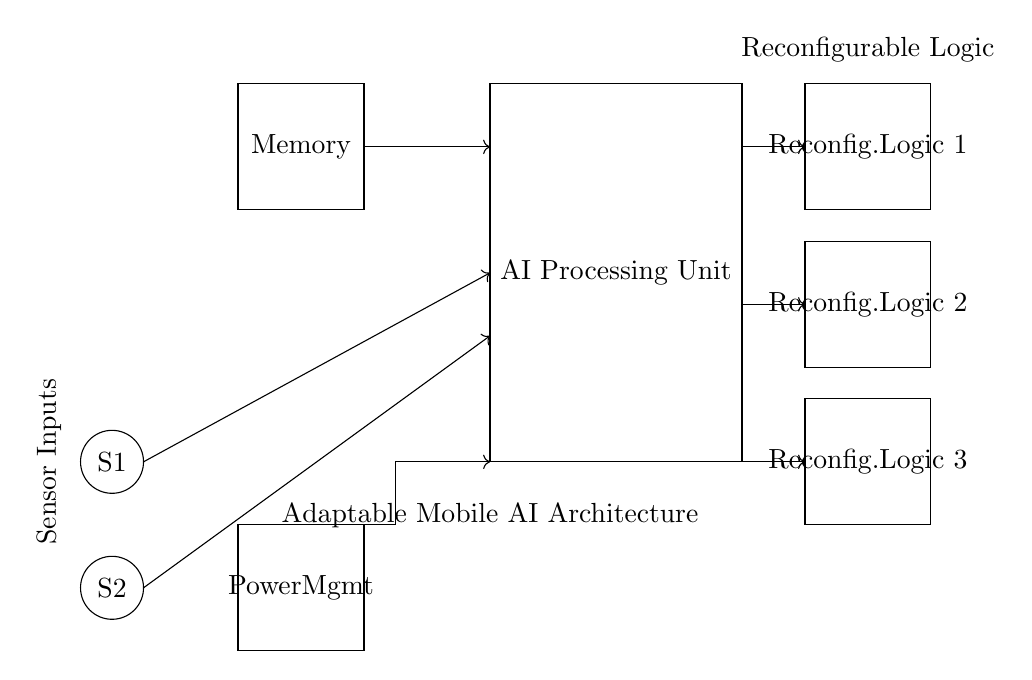What is the main component of this circuit? The main component is the AI Processing Unit, which is represented by the large rectangle at the center of the diagram.
Answer: AI Processing Unit How many reconfigurable logic blocks are present? There are three reconfigurable logic blocks shown in the diagram, which are the rectangles labeled "Reconfig. Logic 1", "Reconfig. Logic 2", and "Reconfig. Logic 3".
Answer: Three What is the role of the memory component? The memory component stores data for the AI Processing Unit, providing necessary information to process input from sensors and manage operations.
Answer: Data storage Which components receive input from sensors? The components that receive sensor input are the AI Processing Unit and the reconfigurable logic blocks, which are connected to sensor inputs labeled S1 and S2.
Answer: AI Processing Unit and Reconfigurable Logic Blocks How does power management affect the circuit's operation? The Power Management component regulates and supplies power to the entire circuit, ensuring that all components operate within their required voltage levels. If power is insufficient, the system fails to function correctly.
Answer: Regulates power supply What is the direction of the flow from the sensors? The flow from the sensors is directed towards the AI Processing Unit and the reconfigurable logic blocks as shown by the arrows pointing from the sensor inputs (S1 and S2) towards those components.
Answer: Towards AI Processing Unit and Logic Blocks How does the circuit accommodate adaptability for AI processing? The circuit uses reconfigurable logic blocks, allowing it to change connections and functions based on the specific AI processing tasks required, enabling adaptability for varied AI workloads.
Answer: Uses reconfigurable logic 